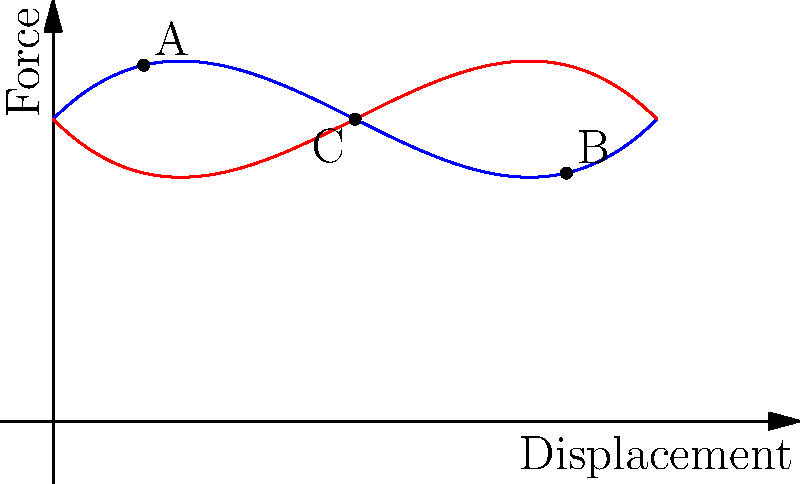In a school's science lab, you're demonstrating a spring-mass system under harmonic excitation to showcase the importance of proper equipment for hands-on learning. The force-displacement curve is shown above. What does the area enclosed by the curve represent, and how does it relate to the system's behavior? To understand the significance of the force-displacement curve for a spring-mass system under harmonic excitation, let's break it down step-by-step:

1) The blue curve represents the loading phase, while the red curve represents the unloading phase of the system.

2) The enclosed area between these curves is key to understanding the system's behavior.

3) This enclosed area represents the energy dissipated per cycle of oscillation. In physical terms, it's the work done by damping forces in the system.

4) The presence of this enclosed area indicates that the system is experiencing hysteresis. Hysteresis in a spring-mass system means that the system doesn't return all the energy input during loading; some energy is lost to the environment.

5) The amount of energy dissipated is directly proportional to the area enclosed by the curve. A larger area means more energy dissipation and higher damping in the system.

6) In the context of harmonic excitation:
   - Point A represents the start of loading
   - Point B represents maximum displacement
   - Point C represents a point during unloading where the force is less than during loading for the same displacement

7) The difference between the loading and unloading curves (e.g., the vertical distance between points on the blue and red curves at the same displacement) represents the damping force at that displacement.

8) In a perfectly elastic system without damping, the loading and unloading curves would overlap, resulting in no enclosed area and no energy dissipation.

This demonstration helps illustrate the importance of understanding energy dissipation in real-world mechanical systems, emphasizing the need for proper equipment in science labs for effective, hands-on learning experiences.
Answer: Energy dissipated per cycle due to damping 